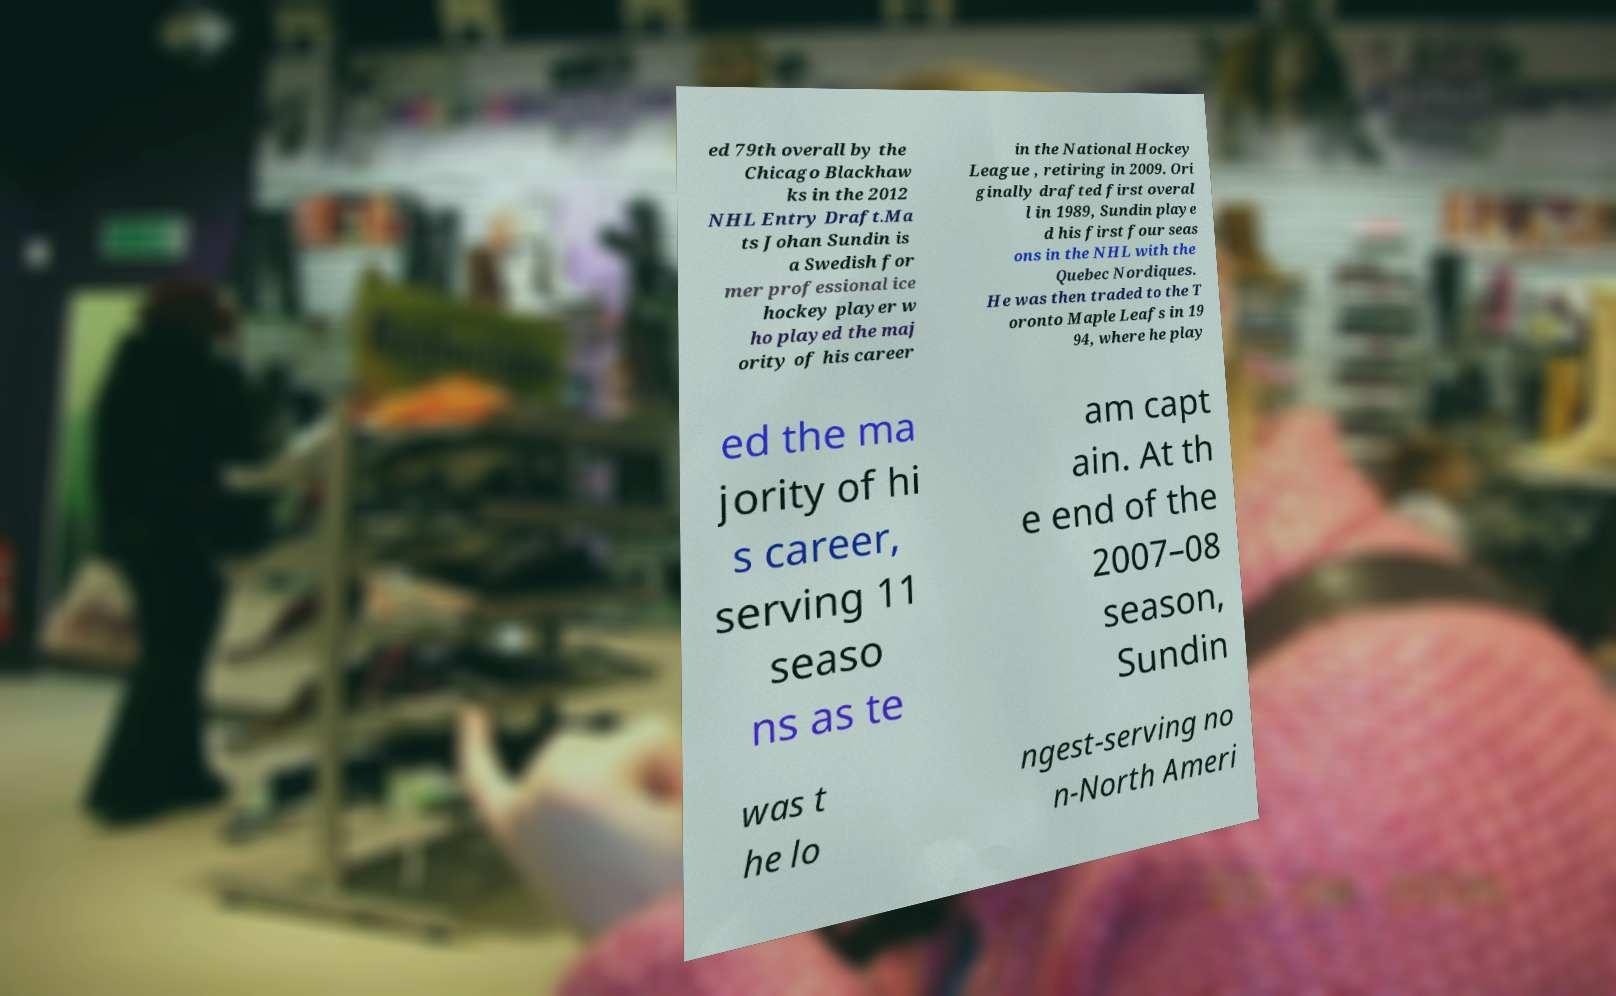Can you accurately transcribe the text from the provided image for me? ed 79th overall by the Chicago Blackhaw ks in the 2012 NHL Entry Draft.Ma ts Johan Sundin is a Swedish for mer professional ice hockey player w ho played the maj ority of his career in the National Hockey League , retiring in 2009. Ori ginally drafted first overal l in 1989, Sundin playe d his first four seas ons in the NHL with the Quebec Nordiques. He was then traded to the T oronto Maple Leafs in 19 94, where he play ed the ma jority of hi s career, serving 11 seaso ns as te am capt ain. At th e end of the 2007–08 season, Sundin was t he lo ngest-serving no n-North Ameri 